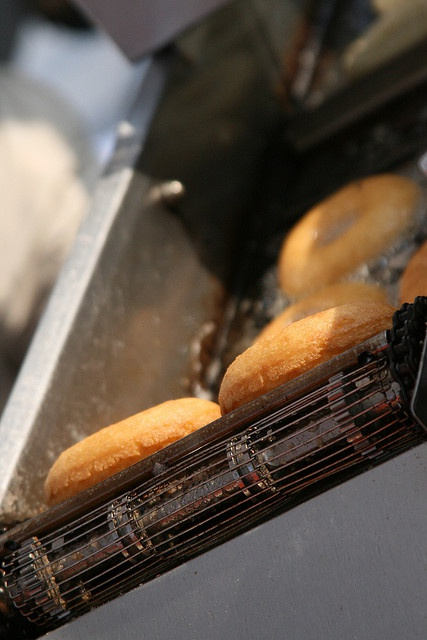Describe the objects in this image and their specific colors. I can see donut in black, olive, gray, and orange tones, donut in black, brown, orange, maroon, and tan tones, donut in black, orange, brown, and tan tones, and donut in black, brown, and maroon tones in this image. 